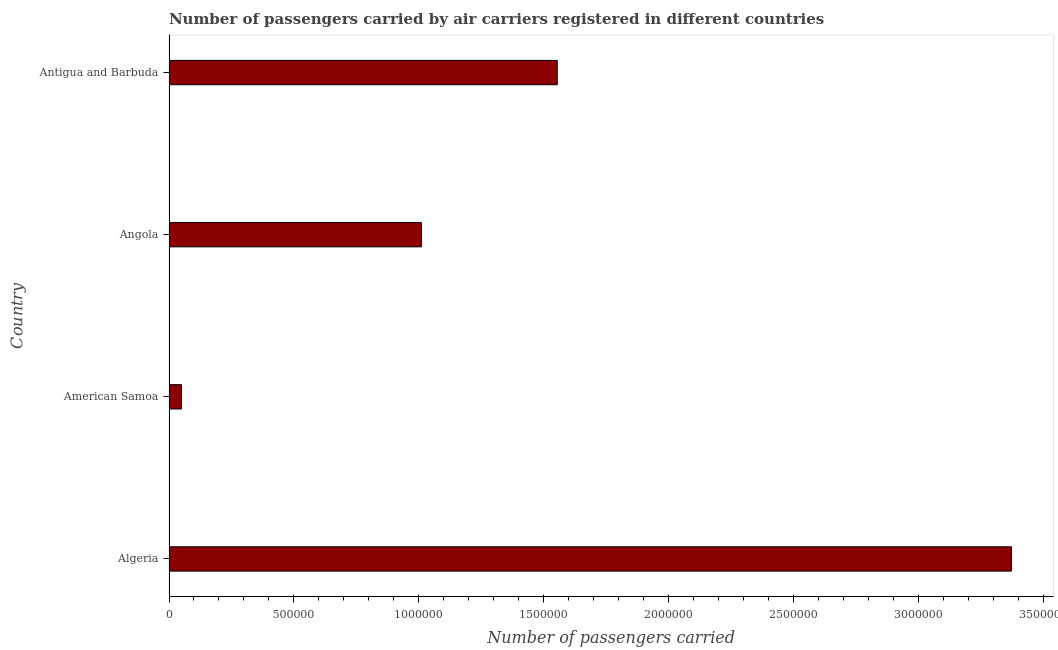Does the graph contain any zero values?
Provide a succinct answer. No. What is the title of the graph?
Make the answer very short. Number of passengers carried by air carriers registered in different countries. What is the label or title of the X-axis?
Your answer should be very brief. Number of passengers carried. What is the label or title of the Y-axis?
Provide a succinct answer. Country. What is the number of passengers carried in American Samoa?
Provide a succinct answer. 4.98e+04. Across all countries, what is the maximum number of passengers carried?
Provide a succinct answer. 3.37e+06. Across all countries, what is the minimum number of passengers carried?
Give a very brief answer. 4.98e+04. In which country was the number of passengers carried maximum?
Your response must be concise. Algeria. In which country was the number of passengers carried minimum?
Keep it short and to the point. American Samoa. What is the sum of the number of passengers carried?
Keep it short and to the point. 5.99e+06. What is the difference between the number of passengers carried in American Samoa and Angola?
Give a very brief answer. -9.60e+05. What is the average number of passengers carried per country?
Make the answer very short. 1.50e+06. What is the median number of passengers carried?
Keep it short and to the point. 1.28e+06. In how many countries, is the number of passengers carried greater than 2700000 ?
Ensure brevity in your answer.  1. What is the ratio of the number of passengers carried in Algeria to that in Angola?
Keep it short and to the point. 3.34. Is the number of passengers carried in Algeria less than that in Angola?
Give a very brief answer. No. What is the difference between the highest and the second highest number of passengers carried?
Offer a very short reply. 1.82e+06. Is the sum of the number of passengers carried in American Samoa and Antigua and Barbuda greater than the maximum number of passengers carried across all countries?
Ensure brevity in your answer.  No. What is the difference between the highest and the lowest number of passengers carried?
Keep it short and to the point. 3.32e+06. In how many countries, is the number of passengers carried greater than the average number of passengers carried taken over all countries?
Offer a very short reply. 2. How many bars are there?
Your answer should be compact. 4. Are all the bars in the graph horizontal?
Your answer should be very brief. Yes. How many countries are there in the graph?
Keep it short and to the point. 4. Are the values on the major ticks of X-axis written in scientific E-notation?
Provide a short and direct response. No. What is the Number of passengers carried of Algeria?
Offer a terse response. 3.37e+06. What is the Number of passengers carried in American Samoa?
Offer a very short reply. 4.98e+04. What is the Number of passengers carried of Angola?
Your response must be concise. 1.01e+06. What is the Number of passengers carried in Antigua and Barbuda?
Your answer should be compact. 1.55e+06. What is the difference between the Number of passengers carried in Algeria and American Samoa?
Your response must be concise. 3.32e+06. What is the difference between the Number of passengers carried in Algeria and Angola?
Provide a succinct answer. 2.36e+06. What is the difference between the Number of passengers carried in Algeria and Antigua and Barbuda?
Your answer should be very brief. 1.82e+06. What is the difference between the Number of passengers carried in American Samoa and Angola?
Offer a terse response. -9.60e+05. What is the difference between the Number of passengers carried in American Samoa and Antigua and Barbuda?
Provide a short and direct response. -1.50e+06. What is the difference between the Number of passengers carried in Angola and Antigua and Barbuda?
Your answer should be compact. -5.44e+05. What is the ratio of the Number of passengers carried in Algeria to that in American Samoa?
Offer a terse response. 67.75. What is the ratio of the Number of passengers carried in Algeria to that in Angola?
Ensure brevity in your answer.  3.34. What is the ratio of the Number of passengers carried in Algeria to that in Antigua and Barbuda?
Offer a very short reply. 2.17. What is the ratio of the Number of passengers carried in American Samoa to that in Angola?
Your response must be concise. 0.05. What is the ratio of the Number of passengers carried in American Samoa to that in Antigua and Barbuda?
Provide a succinct answer. 0.03. What is the ratio of the Number of passengers carried in Angola to that in Antigua and Barbuda?
Provide a short and direct response. 0.65. 